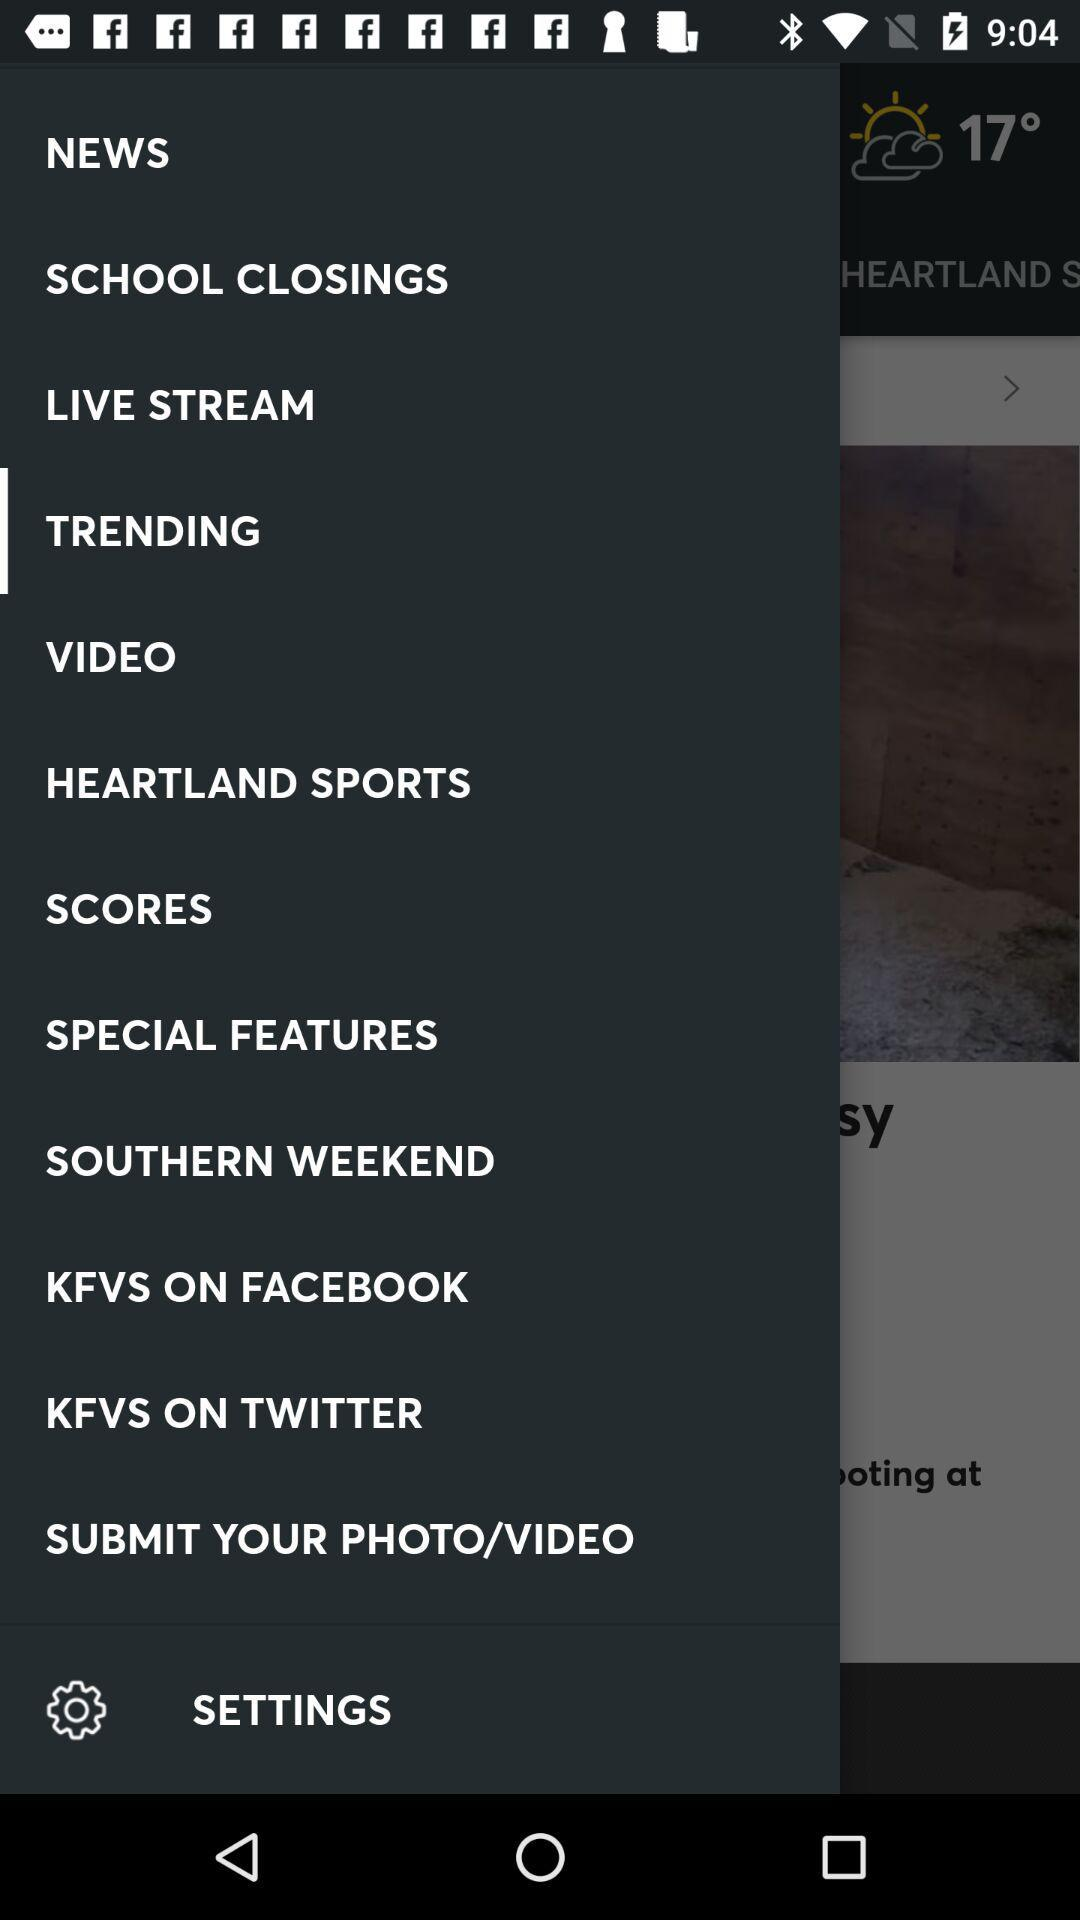How many degrees is the temperature?
Answer the question using a single word or phrase. 17° 